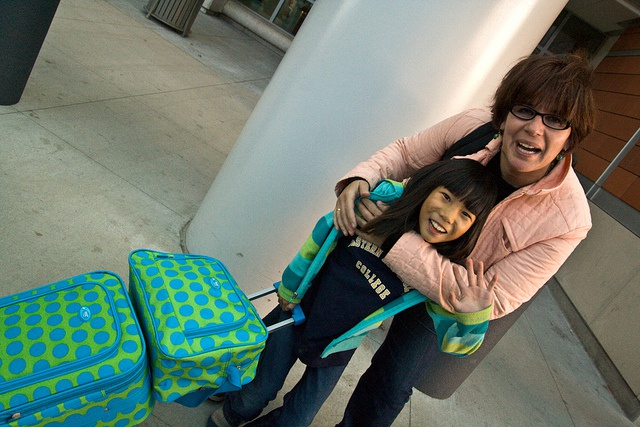Describe the objects in this image and their specific colors. I can see people in black, tan, gray, and maroon tones, people in black, teal, and gray tones, suitcase in black, teal, and green tones, suitcase in black, lightblue, lightgreen, and teal tones, and handbag in black, tan, gray, and pink tones in this image. 